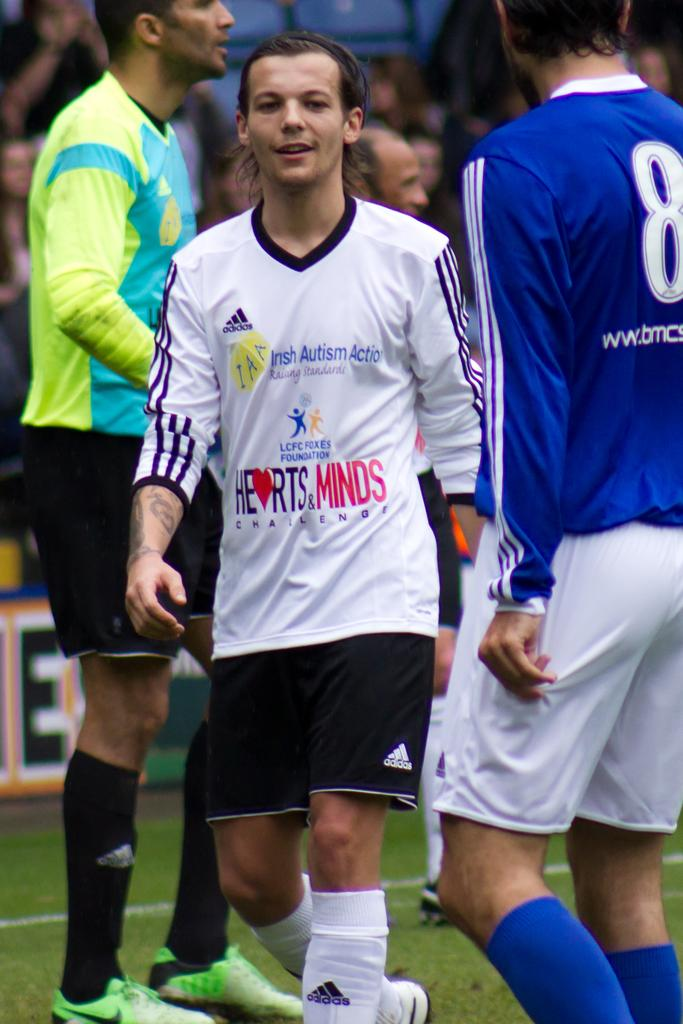How many persons are standing in the image? There are three persons standing in the image. Can you describe the presence of other people in the image? Yes, there is a group of people in the background of the image. What type of vegetable is being held by the sister of the person in the image? There is no sister or vegetable present in the image. 